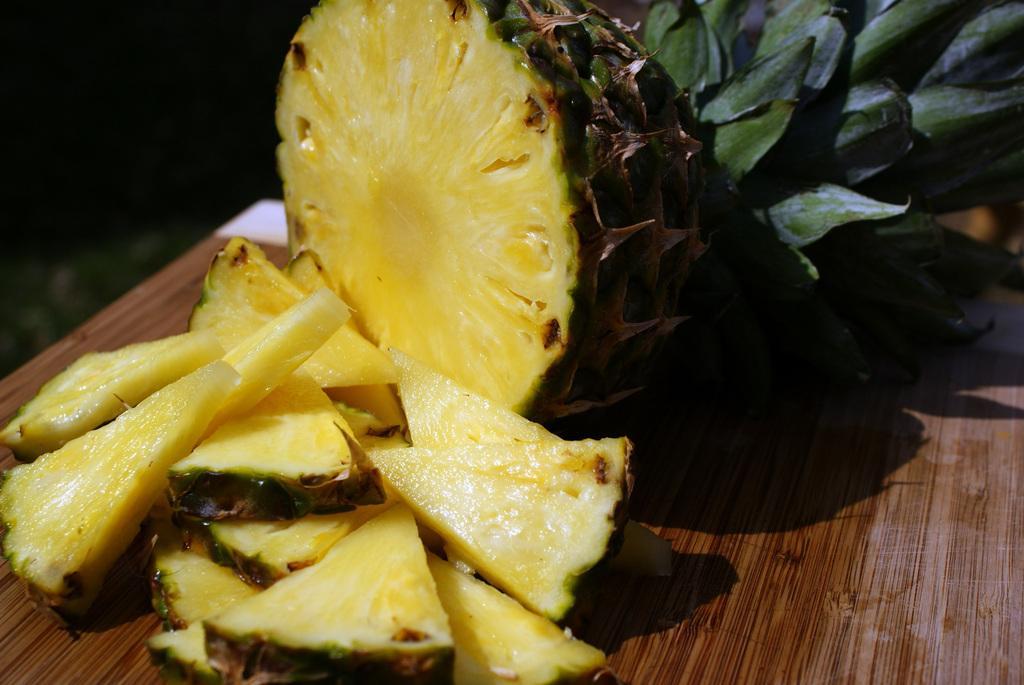Could you give a brief overview of what you see in this image? In this image there is fruit in the center which is on the brown colour surface 